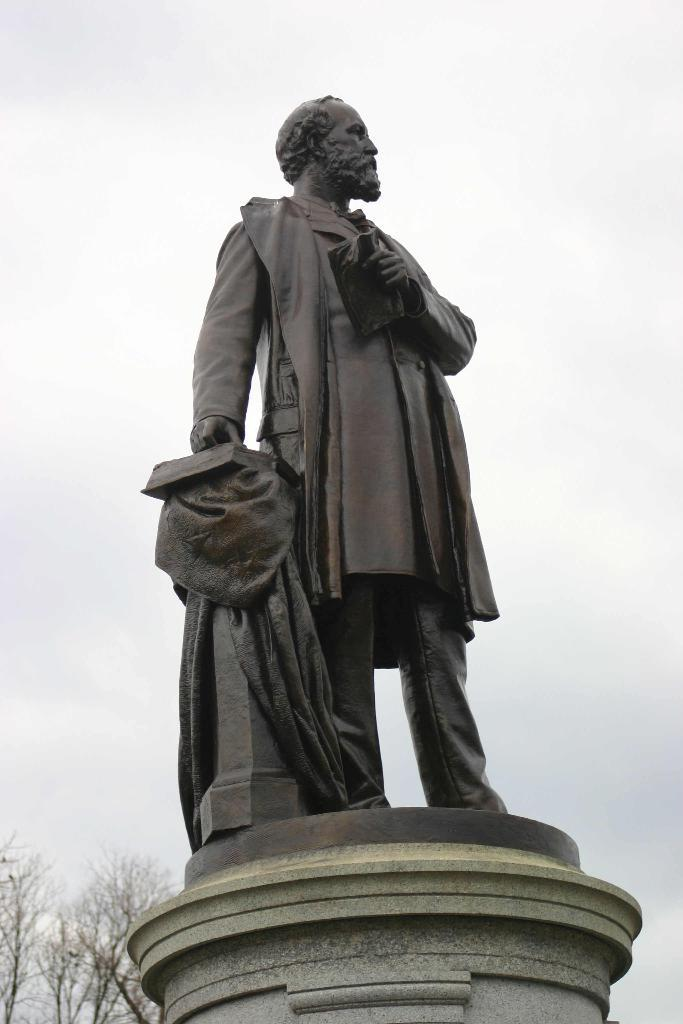What is the main subject of the image? There is a statue of a person in the image. What is the statue holding in its hands? The statue is holding a book and a cloth. What can be seen in the bottom left corner of the image? There are trees in the left bottom of the image. What is visible in the background of the image? The sky is visible in the background of the image. What is the queen's income in the image? There is no queen present in the image, so it is not possible to determine her income. 